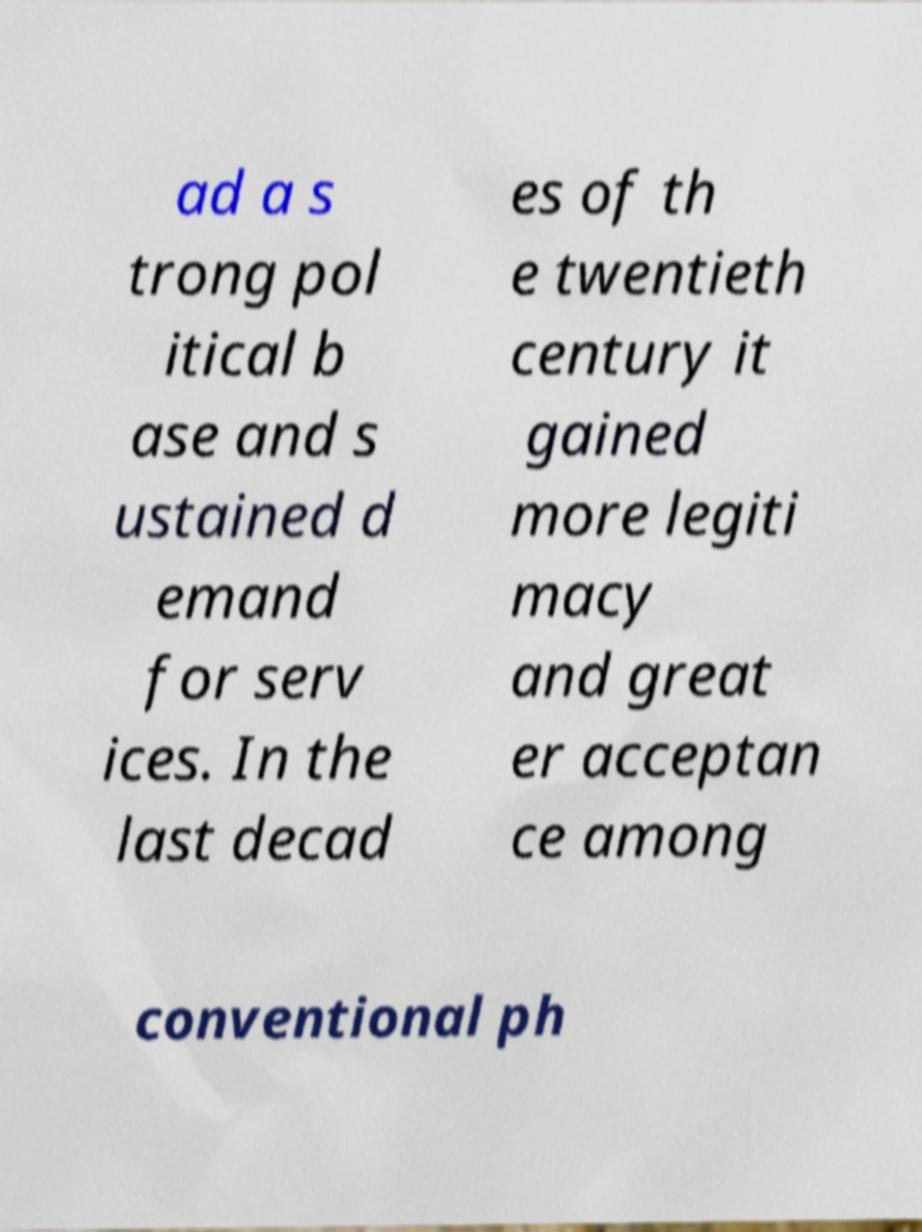Can you read and provide the text displayed in the image?This photo seems to have some interesting text. Can you extract and type it out for me? ad a s trong pol itical b ase and s ustained d emand for serv ices. In the last decad es of th e twentieth century it gained more legiti macy and great er acceptan ce among conventional ph 